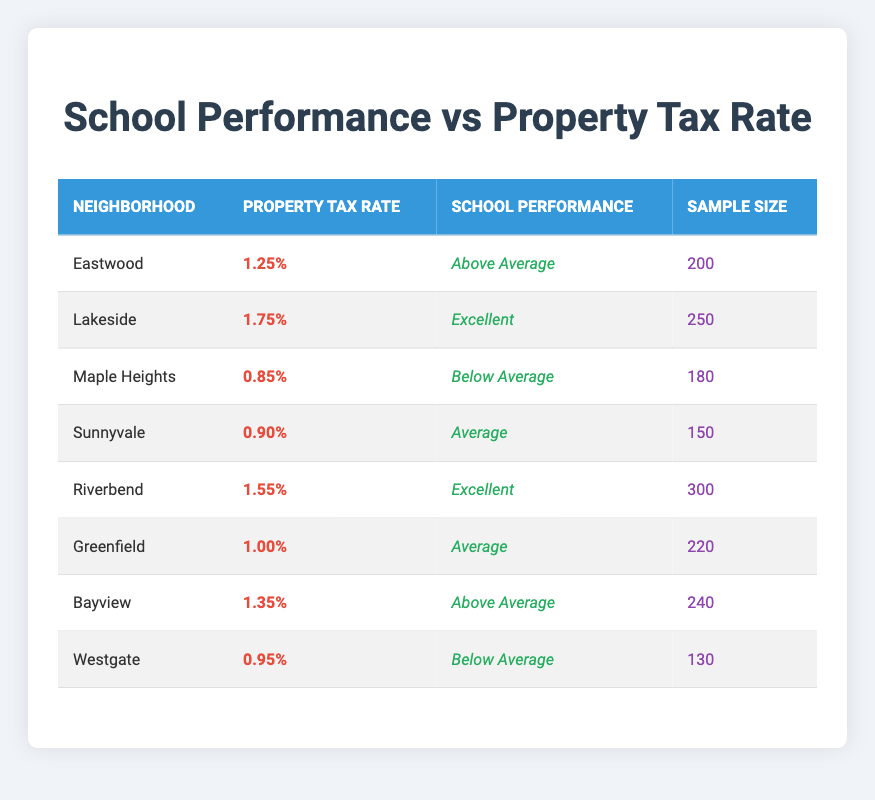What is the property tax rate for Lakeside? The table lists Lakeside as having a property tax rate of 1.75%. This information is directly found in the row corresponding to the Lakeside neighborhood.
Answer: 1.75% Which neighborhood has the lowest property tax rate? By examining the property tax rates listed, Maple Heights has the lowest rate at 0.85%. This can be verified by comparing all the values in the property tax rate column.
Answer: Maple Heights What is the average sample size of neighborhoods with "Excellent" school performance? The neighborhoods with "Excellent" performance are Lakeside and Riverbend, with sample sizes of 250 and 300, respectively. The average is calculated as (250 + 300) / 2 = 275.
Answer: 275 Are there more neighborhoods with "Below Average" school performance than those with "Above Average"? There are 2 neighborhoods (Maple Heights and Westgate) with "Below Average" performance and 3 neighborhoods (Eastwood, Bayview) with "Above Average." Thus, it is false that there are more "Below Average" neighborhoods.
Answer: No Which neighborhood has "Average" school performance with the highest property tax rate? The neighborhoods with "Average" performance are Sunnyvale and Greenfield, with property tax rates of 0.90% and 1.00%, respectively. Greenfield has the higher rate of 1.00%, making it the answer.
Answer: Greenfield 